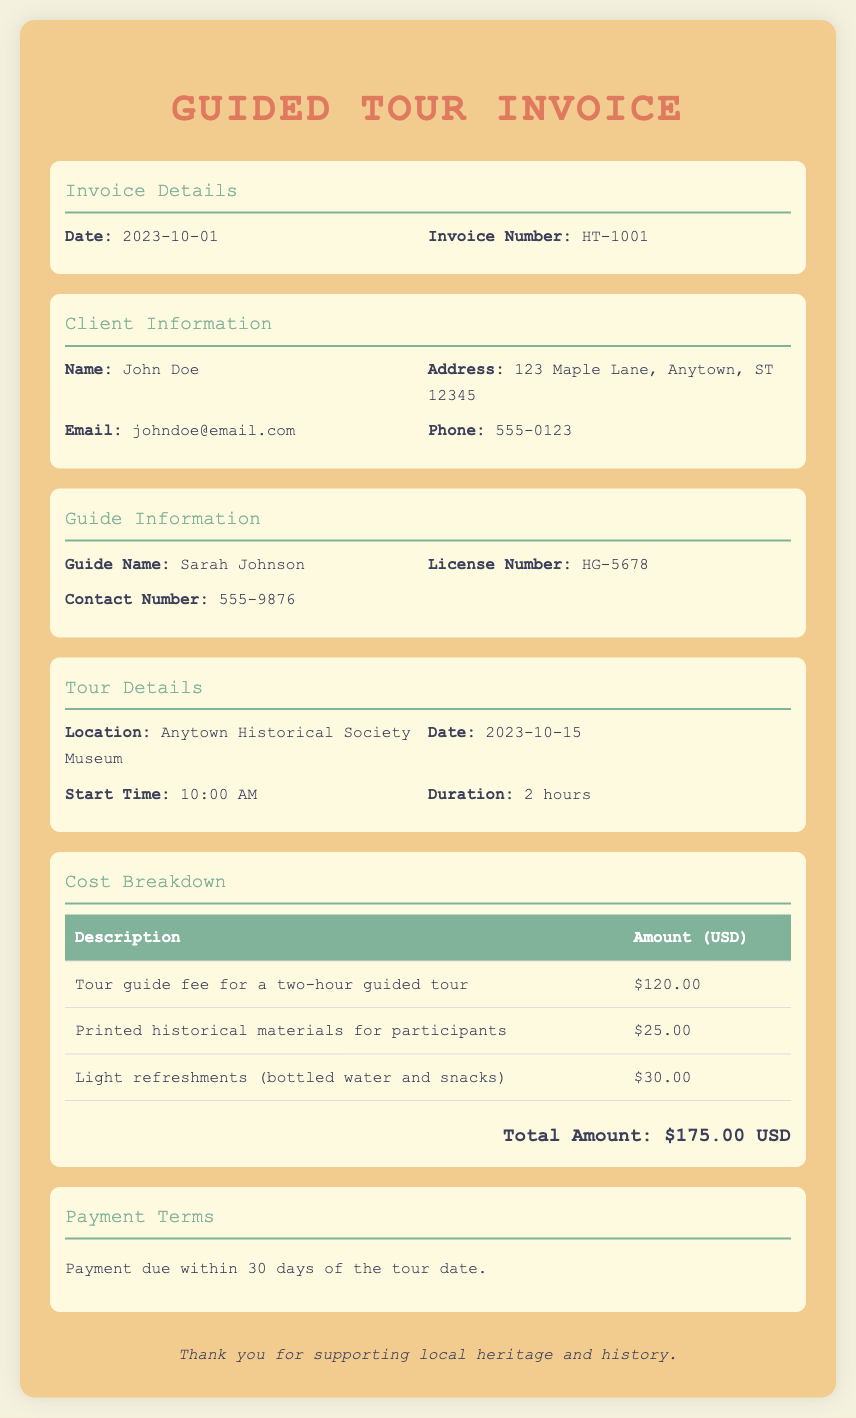What is the invoice number? The invoice number is provided under the Invoice Details section and is unique to the transaction, which is HT-1001.
Answer: HT-1001 Who is the tour guide? The name of the tour guide is listed in the Guide Information section, under the Guide Name header.
Answer: Sarah Johnson What is the total amount due? The total amount due is calculated from the cost breakdown section, which sums up all costs, arriving at $175.00 USD.
Answer: $175.00 USD What is the duration of the tour? The tour duration is mentioned in the Tour Details section, specifying how long the tour will last.
Answer: 2 hours What are the payment terms? The payment terms outline when the payment is due, consisting of information found in the Payment Terms section of the document.
Answer: within 30 days of the tour date What type of refreshments are included? The refreshments provided are detailed in the Cost Breakdown section, specifying what is included under the light refreshments description.
Answer: bottled water and snacks 